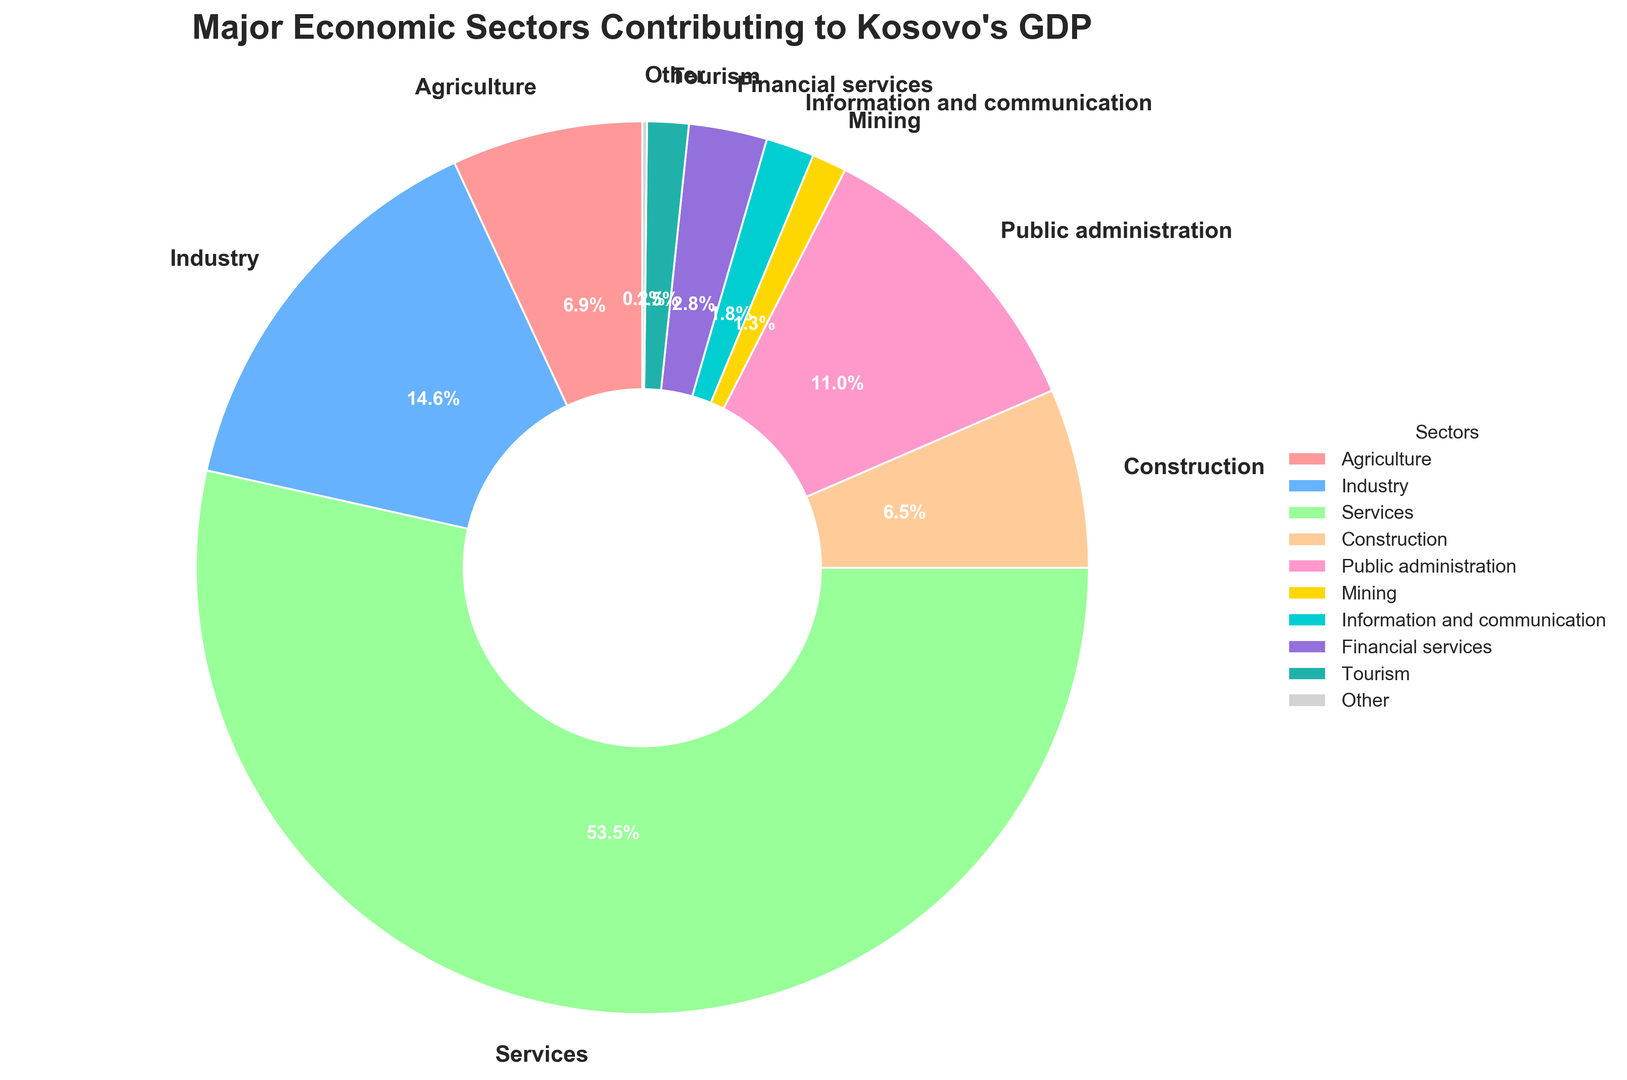What percentage of Kosovo's GDP does the Services sector contribute? Look at the Services label on the pie chart and refer to the percentage mentioned. It shows 64.2%.
Answer: 64.2% Which sector contributes the least to Kosovo’s GDP? Identify the smallest slice in the pie chart. The "Other" sector has the smallest percentage, which is 0.2%.
Answer: Other How much more does the Services sector contribute compared to the Industry sector? Look at the percentages for the Services (64.2%) and Industry (17.5%) sectors. Subtract the Industry percentage from the Services percentage: 64.2 - 17.5 = 46.7.
Answer: 46.7% Which sector has a higher contribution: Public administration or Construction? Compare the percentages of Public administration (13.2%) and Construction (7.8%). Public administration has a higher percentage.
Answer: Public administration What is the combined contribution of Agriculture and Tourism sectors? Sum the percentages of the Agriculture (8.3%) and Tourism (1.8%) sectors. 8.3 + 1.8 = 10.1.
Answer: 10.1% Is the contribution of the Financial services sector greater than the contribution of the Mining sector? Compare the percentages of Financial services (3.4%) and Mining (1.5%). Financial services has a higher percentage.
Answer: Yes What is the difference in GDP contribution between Information and Communication and Tourism sectors? Subtract the percentage of Tourism (1.8%) from the percentage of Information and Communication (2.1%). 2.1 - 1.8 = 0.3.
Answer: 0.3 Which sector is represented by a yellow-colored slice? The yellow-colored slice corresponds to the label "Public administration", which has a percentage of 13.2%.
Answer: Public administration How many sectors contribute less than 10% to Kosovo’s GDP? Identify all sectors whose percentages are less than 10%: Agriculture (8.3%), Construction (7.8%), Mining (1.5%), Information and communication (2.1%), Financial services (3.4%), Tourism (1.8%), Other (0.2%). Count these sectors. There are 7 sectors.
Answer: 7 What is the average GDP contribution of Construction, Public administration, and Mining sectors? Sum the percentages of Construction (7.8%), Public administration (13.2%), and Mining (1.5%). Divide by 3 to get the average: (7.8 + 13.2 + 1.5) / 3 = 7.5.
Answer: 7.5% 